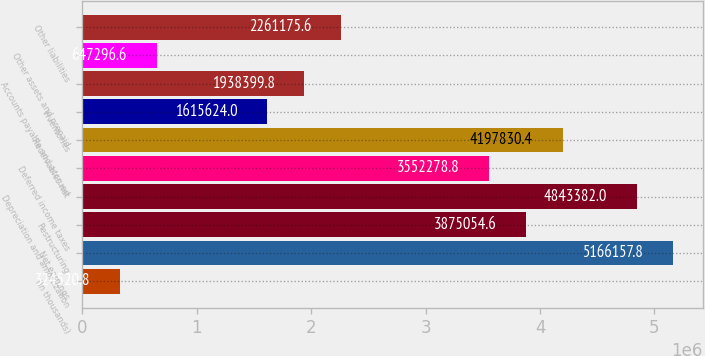Convert chart to OTSL. <chart><loc_0><loc_0><loc_500><loc_500><bar_chart><fcel>(In thousands)<fcel>Net earnings<fcel>Restructuring<fcel>Depreciation and amortization<fcel>Deferred income taxes<fcel>Receivables net<fcel>Inventories<fcel>Accounts payable and accrued<fcel>Other assets and prepaid<fcel>Other liabilities<nl><fcel>324521<fcel>5.16616e+06<fcel>3.87505e+06<fcel>4.84338e+06<fcel>3.55228e+06<fcel>4.19783e+06<fcel>1.61562e+06<fcel>1.9384e+06<fcel>647297<fcel>2.26118e+06<nl></chart> 